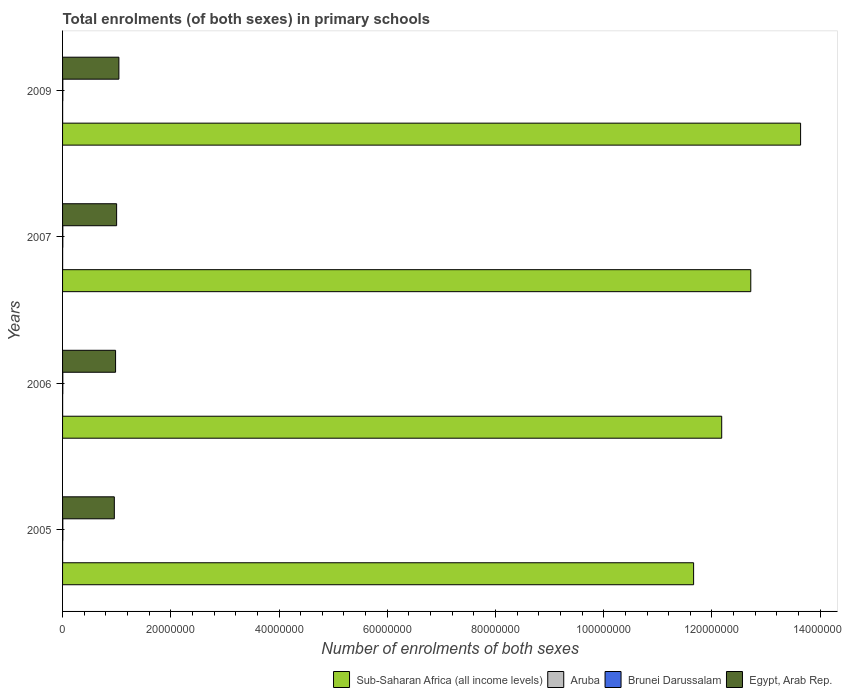How many different coloured bars are there?
Give a very brief answer. 4. How many groups of bars are there?
Offer a terse response. 4. Are the number of bars per tick equal to the number of legend labels?
Offer a very short reply. Yes. Are the number of bars on each tick of the Y-axis equal?
Offer a terse response. Yes. How many bars are there on the 4th tick from the bottom?
Give a very brief answer. 4. In how many cases, is the number of bars for a given year not equal to the number of legend labels?
Your answer should be compact. 0. What is the number of enrolments in primary schools in Egypt, Arab Rep. in 2005?
Offer a terse response. 9.56e+06. Across all years, what is the maximum number of enrolments in primary schools in Brunei Darussalam?
Your answer should be very brief. 4.61e+04. Across all years, what is the minimum number of enrolments in primary schools in Aruba?
Provide a short and direct response. 9944. What is the total number of enrolments in primary schools in Aruba in the graph?
Your answer should be compact. 4.09e+04. What is the difference between the number of enrolments in primary schools in Aruba in 2005 and that in 2006?
Make the answer very short. -140. What is the difference between the number of enrolments in primary schools in Brunei Darussalam in 2006 and the number of enrolments in primary schools in Egypt, Arab Rep. in 2009?
Provide a short and direct response. -1.04e+07. What is the average number of enrolments in primary schools in Brunei Darussalam per year?
Make the answer very short. 4.57e+04. In the year 2005, what is the difference between the number of enrolments in primary schools in Egypt, Arab Rep. and number of enrolments in primary schools in Brunei Darussalam?
Ensure brevity in your answer.  9.52e+06. In how many years, is the number of enrolments in primary schools in Brunei Darussalam greater than 92000000 ?
Ensure brevity in your answer.  0. What is the ratio of the number of enrolments in primary schools in Aruba in 2005 to that in 2007?
Your answer should be very brief. 0.99. What is the difference between the highest and the second highest number of enrolments in primary schools in Egypt, Arab Rep.?
Keep it short and to the point. 4.19e+05. What is the difference between the highest and the lowest number of enrolments in primary schools in Sub-Saharan Africa (all income levels)?
Give a very brief answer. 1.98e+07. In how many years, is the number of enrolments in primary schools in Aruba greater than the average number of enrolments in primary schools in Aruba taken over all years?
Your answer should be compact. 3. Is it the case that in every year, the sum of the number of enrolments in primary schools in Aruba and number of enrolments in primary schools in Brunei Darussalam is greater than the sum of number of enrolments in primary schools in Sub-Saharan Africa (all income levels) and number of enrolments in primary schools in Egypt, Arab Rep.?
Your answer should be compact. No. What does the 1st bar from the top in 2006 represents?
Offer a very short reply. Egypt, Arab Rep. What does the 1st bar from the bottom in 2009 represents?
Your answer should be very brief. Sub-Saharan Africa (all income levels). Is it the case that in every year, the sum of the number of enrolments in primary schools in Aruba and number of enrolments in primary schools in Brunei Darussalam is greater than the number of enrolments in primary schools in Sub-Saharan Africa (all income levels)?
Make the answer very short. No. How many years are there in the graph?
Your answer should be compact. 4. Does the graph contain grids?
Give a very brief answer. No. How many legend labels are there?
Your answer should be compact. 4. How are the legend labels stacked?
Make the answer very short. Horizontal. What is the title of the graph?
Offer a terse response. Total enrolments (of both sexes) in primary schools. Does "Canada" appear as one of the legend labels in the graph?
Make the answer very short. No. What is the label or title of the X-axis?
Keep it short and to the point. Number of enrolments of both sexes. What is the Number of enrolments of both sexes in Sub-Saharan Africa (all income levels) in 2005?
Ensure brevity in your answer.  1.17e+08. What is the Number of enrolments of both sexes of Aruba in 2005?
Offer a terse response. 1.02e+04. What is the Number of enrolments of both sexes in Brunei Darussalam in 2005?
Provide a short and direct response. 4.60e+04. What is the Number of enrolments of both sexes in Egypt, Arab Rep. in 2005?
Offer a very short reply. 9.56e+06. What is the Number of enrolments of both sexes in Sub-Saharan Africa (all income levels) in 2006?
Your answer should be very brief. 1.22e+08. What is the Number of enrolments of both sexes of Aruba in 2006?
Offer a very short reply. 1.04e+04. What is the Number of enrolments of both sexes in Brunei Darussalam in 2006?
Your answer should be very brief. 4.61e+04. What is the Number of enrolments of both sexes in Egypt, Arab Rep. in 2006?
Offer a very short reply. 9.79e+06. What is the Number of enrolments of both sexes in Sub-Saharan Africa (all income levels) in 2007?
Ensure brevity in your answer.  1.27e+08. What is the Number of enrolments of both sexes in Aruba in 2007?
Your answer should be compact. 1.03e+04. What is the Number of enrolments of both sexes in Brunei Darussalam in 2007?
Your response must be concise. 4.60e+04. What is the Number of enrolments of both sexes of Egypt, Arab Rep. in 2007?
Your answer should be compact. 9.99e+06. What is the Number of enrolments of both sexes of Sub-Saharan Africa (all income levels) in 2009?
Offer a terse response. 1.36e+08. What is the Number of enrolments of both sexes in Aruba in 2009?
Your response must be concise. 9944. What is the Number of enrolments of both sexes in Brunei Darussalam in 2009?
Your answer should be very brief. 4.47e+04. What is the Number of enrolments of both sexes of Egypt, Arab Rep. in 2009?
Give a very brief answer. 1.04e+07. Across all years, what is the maximum Number of enrolments of both sexes of Sub-Saharan Africa (all income levels)?
Offer a terse response. 1.36e+08. Across all years, what is the maximum Number of enrolments of both sexes in Aruba?
Offer a very short reply. 1.04e+04. Across all years, what is the maximum Number of enrolments of both sexes of Brunei Darussalam?
Provide a short and direct response. 4.61e+04. Across all years, what is the maximum Number of enrolments of both sexes of Egypt, Arab Rep.?
Offer a very short reply. 1.04e+07. Across all years, what is the minimum Number of enrolments of both sexes in Sub-Saharan Africa (all income levels)?
Provide a short and direct response. 1.17e+08. Across all years, what is the minimum Number of enrolments of both sexes in Aruba?
Give a very brief answer. 9944. Across all years, what is the minimum Number of enrolments of both sexes in Brunei Darussalam?
Keep it short and to the point. 4.47e+04. Across all years, what is the minimum Number of enrolments of both sexes of Egypt, Arab Rep.?
Offer a terse response. 9.56e+06. What is the total Number of enrolments of both sexes of Sub-Saharan Africa (all income levels) in the graph?
Your answer should be very brief. 5.02e+08. What is the total Number of enrolments of both sexes of Aruba in the graph?
Your answer should be very brief. 4.09e+04. What is the total Number of enrolments of both sexes of Brunei Darussalam in the graph?
Your response must be concise. 1.83e+05. What is the total Number of enrolments of both sexes in Egypt, Arab Rep. in the graph?
Ensure brevity in your answer.  3.98e+07. What is the difference between the Number of enrolments of both sexes of Sub-Saharan Africa (all income levels) in 2005 and that in 2006?
Offer a terse response. -5.19e+06. What is the difference between the Number of enrolments of both sexes of Aruba in 2005 and that in 2006?
Your response must be concise. -140. What is the difference between the Number of enrolments of both sexes in Brunei Darussalam in 2005 and that in 2006?
Offer a terse response. -74. What is the difference between the Number of enrolments of both sexes of Egypt, Arab Rep. in 2005 and that in 2006?
Offer a terse response. -2.31e+05. What is the difference between the Number of enrolments of both sexes in Sub-Saharan Africa (all income levels) in 2005 and that in 2007?
Your response must be concise. -1.06e+07. What is the difference between the Number of enrolments of both sexes of Aruba in 2005 and that in 2007?
Make the answer very short. -96. What is the difference between the Number of enrolments of both sexes of Egypt, Arab Rep. in 2005 and that in 2007?
Ensure brevity in your answer.  -4.25e+05. What is the difference between the Number of enrolments of both sexes in Sub-Saharan Africa (all income levels) in 2005 and that in 2009?
Offer a terse response. -1.98e+07. What is the difference between the Number of enrolments of both sexes in Aruba in 2005 and that in 2009?
Provide a short and direct response. 306. What is the difference between the Number of enrolments of both sexes in Brunei Darussalam in 2005 and that in 2009?
Keep it short and to the point. 1331. What is the difference between the Number of enrolments of both sexes of Egypt, Arab Rep. in 2005 and that in 2009?
Offer a terse response. -8.44e+05. What is the difference between the Number of enrolments of both sexes in Sub-Saharan Africa (all income levels) in 2006 and that in 2007?
Provide a short and direct response. -5.37e+06. What is the difference between the Number of enrolments of both sexes of Brunei Darussalam in 2006 and that in 2007?
Offer a terse response. 114. What is the difference between the Number of enrolments of both sexes of Egypt, Arab Rep. in 2006 and that in 2007?
Your response must be concise. -1.94e+05. What is the difference between the Number of enrolments of both sexes of Sub-Saharan Africa (all income levels) in 2006 and that in 2009?
Offer a terse response. -1.46e+07. What is the difference between the Number of enrolments of both sexes in Aruba in 2006 and that in 2009?
Offer a terse response. 446. What is the difference between the Number of enrolments of both sexes in Brunei Darussalam in 2006 and that in 2009?
Make the answer very short. 1405. What is the difference between the Number of enrolments of both sexes in Egypt, Arab Rep. in 2006 and that in 2009?
Keep it short and to the point. -6.13e+05. What is the difference between the Number of enrolments of both sexes of Sub-Saharan Africa (all income levels) in 2007 and that in 2009?
Provide a succinct answer. -9.21e+06. What is the difference between the Number of enrolments of both sexes in Aruba in 2007 and that in 2009?
Give a very brief answer. 402. What is the difference between the Number of enrolments of both sexes in Brunei Darussalam in 2007 and that in 2009?
Give a very brief answer. 1291. What is the difference between the Number of enrolments of both sexes in Egypt, Arab Rep. in 2007 and that in 2009?
Your response must be concise. -4.19e+05. What is the difference between the Number of enrolments of both sexes in Sub-Saharan Africa (all income levels) in 2005 and the Number of enrolments of both sexes in Aruba in 2006?
Provide a succinct answer. 1.17e+08. What is the difference between the Number of enrolments of both sexes of Sub-Saharan Africa (all income levels) in 2005 and the Number of enrolments of both sexes of Brunei Darussalam in 2006?
Make the answer very short. 1.17e+08. What is the difference between the Number of enrolments of both sexes of Sub-Saharan Africa (all income levels) in 2005 and the Number of enrolments of both sexes of Egypt, Arab Rep. in 2006?
Your answer should be very brief. 1.07e+08. What is the difference between the Number of enrolments of both sexes of Aruba in 2005 and the Number of enrolments of both sexes of Brunei Darussalam in 2006?
Your response must be concise. -3.58e+04. What is the difference between the Number of enrolments of both sexes of Aruba in 2005 and the Number of enrolments of both sexes of Egypt, Arab Rep. in 2006?
Provide a short and direct response. -9.78e+06. What is the difference between the Number of enrolments of both sexes in Brunei Darussalam in 2005 and the Number of enrolments of both sexes in Egypt, Arab Rep. in 2006?
Provide a short and direct response. -9.75e+06. What is the difference between the Number of enrolments of both sexes of Sub-Saharan Africa (all income levels) in 2005 and the Number of enrolments of both sexes of Aruba in 2007?
Your response must be concise. 1.17e+08. What is the difference between the Number of enrolments of both sexes in Sub-Saharan Africa (all income levels) in 2005 and the Number of enrolments of both sexes in Brunei Darussalam in 2007?
Make the answer very short. 1.17e+08. What is the difference between the Number of enrolments of both sexes of Sub-Saharan Africa (all income levels) in 2005 and the Number of enrolments of both sexes of Egypt, Arab Rep. in 2007?
Ensure brevity in your answer.  1.07e+08. What is the difference between the Number of enrolments of both sexes of Aruba in 2005 and the Number of enrolments of both sexes of Brunei Darussalam in 2007?
Provide a short and direct response. -3.57e+04. What is the difference between the Number of enrolments of both sexes in Aruba in 2005 and the Number of enrolments of both sexes in Egypt, Arab Rep. in 2007?
Keep it short and to the point. -9.98e+06. What is the difference between the Number of enrolments of both sexes of Brunei Darussalam in 2005 and the Number of enrolments of both sexes of Egypt, Arab Rep. in 2007?
Your answer should be very brief. -9.94e+06. What is the difference between the Number of enrolments of both sexes in Sub-Saharan Africa (all income levels) in 2005 and the Number of enrolments of both sexes in Aruba in 2009?
Make the answer very short. 1.17e+08. What is the difference between the Number of enrolments of both sexes of Sub-Saharan Africa (all income levels) in 2005 and the Number of enrolments of both sexes of Brunei Darussalam in 2009?
Provide a succinct answer. 1.17e+08. What is the difference between the Number of enrolments of both sexes of Sub-Saharan Africa (all income levels) in 2005 and the Number of enrolments of both sexes of Egypt, Arab Rep. in 2009?
Offer a very short reply. 1.06e+08. What is the difference between the Number of enrolments of both sexes of Aruba in 2005 and the Number of enrolments of both sexes of Brunei Darussalam in 2009?
Provide a succinct answer. -3.44e+04. What is the difference between the Number of enrolments of both sexes in Aruba in 2005 and the Number of enrolments of both sexes in Egypt, Arab Rep. in 2009?
Offer a very short reply. -1.04e+07. What is the difference between the Number of enrolments of both sexes of Brunei Darussalam in 2005 and the Number of enrolments of both sexes of Egypt, Arab Rep. in 2009?
Your answer should be very brief. -1.04e+07. What is the difference between the Number of enrolments of both sexes in Sub-Saharan Africa (all income levels) in 2006 and the Number of enrolments of both sexes in Aruba in 2007?
Offer a very short reply. 1.22e+08. What is the difference between the Number of enrolments of both sexes of Sub-Saharan Africa (all income levels) in 2006 and the Number of enrolments of both sexes of Brunei Darussalam in 2007?
Keep it short and to the point. 1.22e+08. What is the difference between the Number of enrolments of both sexes of Sub-Saharan Africa (all income levels) in 2006 and the Number of enrolments of both sexes of Egypt, Arab Rep. in 2007?
Your answer should be very brief. 1.12e+08. What is the difference between the Number of enrolments of both sexes of Aruba in 2006 and the Number of enrolments of both sexes of Brunei Darussalam in 2007?
Make the answer very short. -3.56e+04. What is the difference between the Number of enrolments of both sexes in Aruba in 2006 and the Number of enrolments of both sexes in Egypt, Arab Rep. in 2007?
Make the answer very short. -9.98e+06. What is the difference between the Number of enrolments of both sexes in Brunei Darussalam in 2006 and the Number of enrolments of both sexes in Egypt, Arab Rep. in 2007?
Offer a very short reply. -9.94e+06. What is the difference between the Number of enrolments of both sexes in Sub-Saharan Africa (all income levels) in 2006 and the Number of enrolments of both sexes in Aruba in 2009?
Make the answer very short. 1.22e+08. What is the difference between the Number of enrolments of both sexes in Sub-Saharan Africa (all income levels) in 2006 and the Number of enrolments of both sexes in Brunei Darussalam in 2009?
Give a very brief answer. 1.22e+08. What is the difference between the Number of enrolments of both sexes of Sub-Saharan Africa (all income levels) in 2006 and the Number of enrolments of both sexes of Egypt, Arab Rep. in 2009?
Make the answer very short. 1.11e+08. What is the difference between the Number of enrolments of both sexes of Aruba in 2006 and the Number of enrolments of both sexes of Brunei Darussalam in 2009?
Your answer should be very brief. -3.43e+04. What is the difference between the Number of enrolments of both sexes in Aruba in 2006 and the Number of enrolments of both sexes in Egypt, Arab Rep. in 2009?
Offer a terse response. -1.04e+07. What is the difference between the Number of enrolments of both sexes of Brunei Darussalam in 2006 and the Number of enrolments of both sexes of Egypt, Arab Rep. in 2009?
Provide a short and direct response. -1.04e+07. What is the difference between the Number of enrolments of both sexes in Sub-Saharan Africa (all income levels) in 2007 and the Number of enrolments of both sexes in Aruba in 2009?
Keep it short and to the point. 1.27e+08. What is the difference between the Number of enrolments of both sexes in Sub-Saharan Africa (all income levels) in 2007 and the Number of enrolments of both sexes in Brunei Darussalam in 2009?
Ensure brevity in your answer.  1.27e+08. What is the difference between the Number of enrolments of both sexes in Sub-Saharan Africa (all income levels) in 2007 and the Number of enrolments of both sexes in Egypt, Arab Rep. in 2009?
Provide a short and direct response. 1.17e+08. What is the difference between the Number of enrolments of both sexes in Aruba in 2007 and the Number of enrolments of both sexes in Brunei Darussalam in 2009?
Keep it short and to the point. -3.43e+04. What is the difference between the Number of enrolments of both sexes of Aruba in 2007 and the Number of enrolments of both sexes of Egypt, Arab Rep. in 2009?
Ensure brevity in your answer.  -1.04e+07. What is the difference between the Number of enrolments of both sexes in Brunei Darussalam in 2007 and the Number of enrolments of both sexes in Egypt, Arab Rep. in 2009?
Ensure brevity in your answer.  -1.04e+07. What is the average Number of enrolments of both sexes of Sub-Saharan Africa (all income levels) per year?
Provide a short and direct response. 1.25e+08. What is the average Number of enrolments of both sexes of Aruba per year?
Make the answer very short. 1.02e+04. What is the average Number of enrolments of both sexes in Brunei Darussalam per year?
Your response must be concise. 4.57e+04. What is the average Number of enrolments of both sexes in Egypt, Arab Rep. per year?
Make the answer very short. 9.94e+06. In the year 2005, what is the difference between the Number of enrolments of both sexes of Sub-Saharan Africa (all income levels) and Number of enrolments of both sexes of Aruba?
Make the answer very short. 1.17e+08. In the year 2005, what is the difference between the Number of enrolments of both sexes of Sub-Saharan Africa (all income levels) and Number of enrolments of both sexes of Brunei Darussalam?
Keep it short and to the point. 1.17e+08. In the year 2005, what is the difference between the Number of enrolments of both sexes in Sub-Saharan Africa (all income levels) and Number of enrolments of both sexes in Egypt, Arab Rep.?
Provide a succinct answer. 1.07e+08. In the year 2005, what is the difference between the Number of enrolments of both sexes in Aruba and Number of enrolments of both sexes in Brunei Darussalam?
Make the answer very short. -3.58e+04. In the year 2005, what is the difference between the Number of enrolments of both sexes of Aruba and Number of enrolments of both sexes of Egypt, Arab Rep.?
Provide a succinct answer. -9.55e+06. In the year 2005, what is the difference between the Number of enrolments of both sexes of Brunei Darussalam and Number of enrolments of both sexes of Egypt, Arab Rep.?
Provide a succinct answer. -9.52e+06. In the year 2006, what is the difference between the Number of enrolments of both sexes in Sub-Saharan Africa (all income levels) and Number of enrolments of both sexes in Aruba?
Make the answer very short. 1.22e+08. In the year 2006, what is the difference between the Number of enrolments of both sexes of Sub-Saharan Africa (all income levels) and Number of enrolments of both sexes of Brunei Darussalam?
Offer a terse response. 1.22e+08. In the year 2006, what is the difference between the Number of enrolments of both sexes of Sub-Saharan Africa (all income levels) and Number of enrolments of both sexes of Egypt, Arab Rep.?
Your answer should be compact. 1.12e+08. In the year 2006, what is the difference between the Number of enrolments of both sexes of Aruba and Number of enrolments of both sexes of Brunei Darussalam?
Your answer should be compact. -3.57e+04. In the year 2006, what is the difference between the Number of enrolments of both sexes of Aruba and Number of enrolments of both sexes of Egypt, Arab Rep.?
Your response must be concise. -9.78e+06. In the year 2006, what is the difference between the Number of enrolments of both sexes of Brunei Darussalam and Number of enrolments of both sexes of Egypt, Arab Rep.?
Ensure brevity in your answer.  -9.75e+06. In the year 2007, what is the difference between the Number of enrolments of both sexes of Sub-Saharan Africa (all income levels) and Number of enrolments of both sexes of Aruba?
Ensure brevity in your answer.  1.27e+08. In the year 2007, what is the difference between the Number of enrolments of both sexes in Sub-Saharan Africa (all income levels) and Number of enrolments of both sexes in Brunei Darussalam?
Give a very brief answer. 1.27e+08. In the year 2007, what is the difference between the Number of enrolments of both sexes in Sub-Saharan Africa (all income levels) and Number of enrolments of both sexes in Egypt, Arab Rep.?
Offer a terse response. 1.17e+08. In the year 2007, what is the difference between the Number of enrolments of both sexes of Aruba and Number of enrolments of both sexes of Brunei Darussalam?
Provide a succinct answer. -3.56e+04. In the year 2007, what is the difference between the Number of enrolments of both sexes of Aruba and Number of enrolments of both sexes of Egypt, Arab Rep.?
Make the answer very short. -9.98e+06. In the year 2007, what is the difference between the Number of enrolments of both sexes of Brunei Darussalam and Number of enrolments of both sexes of Egypt, Arab Rep.?
Ensure brevity in your answer.  -9.94e+06. In the year 2009, what is the difference between the Number of enrolments of both sexes in Sub-Saharan Africa (all income levels) and Number of enrolments of both sexes in Aruba?
Provide a short and direct response. 1.36e+08. In the year 2009, what is the difference between the Number of enrolments of both sexes in Sub-Saharan Africa (all income levels) and Number of enrolments of both sexes in Brunei Darussalam?
Make the answer very short. 1.36e+08. In the year 2009, what is the difference between the Number of enrolments of both sexes in Sub-Saharan Africa (all income levels) and Number of enrolments of both sexes in Egypt, Arab Rep.?
Give a very brief answer. 1.26e+08. In the year 2009, what is the difference between the Number of enrolments of both sexes of Aruba and Number of enrolments of both sexes of Brunei Darussalam?
Offer a very short reply. -3.47e+04. In the year 2009, what is the difference between the Number of enrolments of both sexes of Aruba and Number of enrolments of both sexes of Egypt, Arab Rep.?
Give a very brief answer. -1.04e+07. In the year 2009, what is the difference between the Number of enrolments of both sexes of Brunei Darussalam and Number of enrolments of both sexes of Egypt, Arab Rep.?
Provide a short and direct response. -1.04e+07. What is the ratio of the Number of enrolments of both sexes in Sub-Saharan Africa (all income levels) in 2005 to that in 2006?
Provide a short and direct response. 0.96. What is the ratio of the Number of enrolments of both sexes in Aruba in 2005 to that in 2006?
Provide a succinct answer. 0.99. What is the ratio of the Number of enrolments of both sexes of Brunei Darussalam in 2005 to that in 2006?
Your answer should be compact. 1. What is the ratio of the Number of enrolments of both sexes in Egypt, Arab Rep. in 2005 to that in 2006?
Give a very brief answer. 0.98. What is the ratio of the Number of enrolments of both sexes of Sub-Saharan Africa (all income levels) in 2005 to that in 2007?
Provide a succinct answer. 0.92. What is the ratio of the Number of enrolments of both sexes in Egypt, Arab Rep. in 2005 to that in 2007?
Give a very brief answer. 0.96. What is the ratio of the Number of enrolments of both sexes in Sub-Saharan Africa (all income levels) in 2005 to that in 2009?
Make the answer very short. 0.85. What is the ratio of the Number of enrolments of both sexes of Aruba in 2005 to that in 2009?
Keep it short and to the point. 1.03. What is the ratio of the Number of enrolments of both sexes in Brunei Darussalam in 2005 to that in 2009?
Offer a terse response. 1.03. What is the ratio of the Number of enrolments of both sexes in Egypt, Arab Rep. in 2005 to that in 2009?
Your response must be concise. 0.92. What is the ratio of the Number of enrolments of both sexes of Sub-Saharan Africa (all income levels) in 2006 to that in 2007?
Offer a terse response. 0.96. What is the ratio of the Number of enrolments of both sexes in Aruba in 2006 to that in 2007?
Your answer should be very brief. 1. What is the ratio of the Number of enrolments of both sexes of Egypt, Arab Rep. in 2006 to that in 2007?
Your answer should be very brief. 0.98. What is the ratio of the Number of enrolments of both sexes of Sub-Saharan Africa (all income levels) in 2006 to that in 2009?
Provide a succinct answer. 0.89. What is the ratio of the Number of enrolments of both sexes in Aruba in 2006 to that in 2009?
Your answer should be very brief. 1.04. What is the ratio of the Number of enrolments of both sexes of Brunei Darussalam in 2006 to that in 2009?
Provide a succinct answer. 1.03. What is the ratio of the Number of enrolments of both sexes of Egypt, Arab Rep. in 2006 to that in 2009?
Your response must be concise. 0.94. What is the ratio of the Number of enrolments of both sexes of Sub-Saharan Africa (all income levels) in 2007 to that in 2009?
Offer a very short reply. 0.93. What is the ratio of the Number of enrolments of both sexes in Aruba in 2007 to that in 2009?
Give a very brief answer. 1.04. What is the ratio of the Number of enrolments of both sexes of Brunei Darussalam in 2007 to that in 2009?
Make the answer very short. 1.03. What is the ratio of the Number of enrolments of both sexes of Egypt, Arab Rep. in 2007 to that in 2009?
Your response must be concise. 0.96. What is the difference between the highest and the second highest Number of enrolments of both sexes of Sub-Saharan Africa (all income levels)?
Give a very brief answer. 9.21e+06. What is the difference between the highest and the second highest Number of enrolments of both sexes in Aruba?
Offer a terse response. 44. What is the difference between the highest and the second highest Number of enrolments of both sexes of Brunei Darussalam?
Your answer should be compact. 74. What is the difference between the highest and the second highest Number of enrolments of both sexes of Egypt, Arab Rep.?
Offer a very short reply. 4.19e+05. What is the difference between the highest and the lowest Number of enrolments of both sexes of Sub-Saharan Africa (all income levels)?
Ensure brevity in your answer.  1.98e+07. What is the difference between the highest and the lowest Number of enrolments of both sexes of Aruba?
Your answer should be compact. 446. What is the difference between the highest and the lowest Number of enrolments of both sexes of Brunei Darussalam?
Ensure brevity in your answer.  1405. What is the difference between the highest and the lowest Number of enrolments of both sexes of Egypt, Arab Rep.?
Keep it short and to the point. 8.44e+05. 